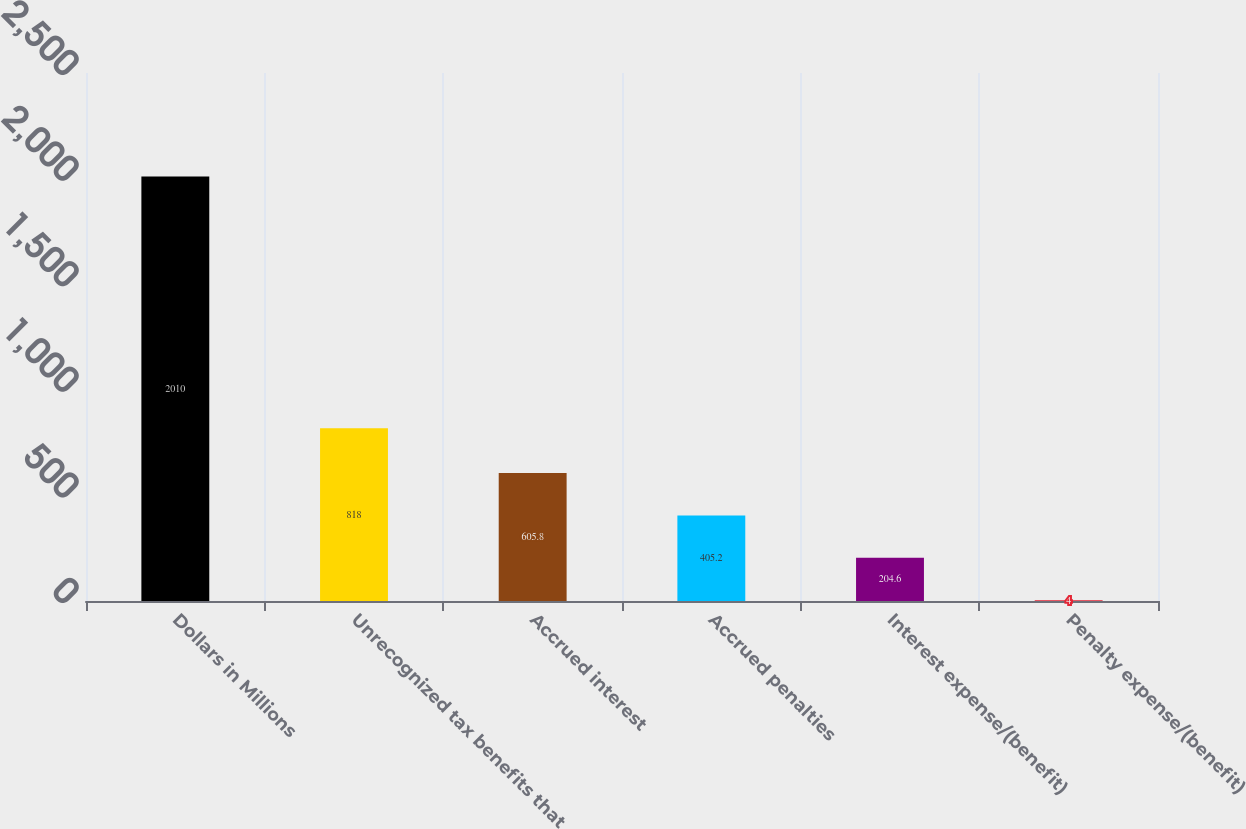Convert chart to OTSL. <chart><loc_0><loc_0><loc_500><loc_500><bar_chart><fcel>Dollars in Millions<fcel>Unrecognized tax benefits that<fcel>Accrued interest<fcel>Accrued penalties<fcel>Interest expense/(benefit)<fcel>Penalty expense/(benefit)<nl><fcel>2010<fcel>818<fcel>605.8<fcel>405.2<fcel>204.6<fcel>4<nl></chart> 